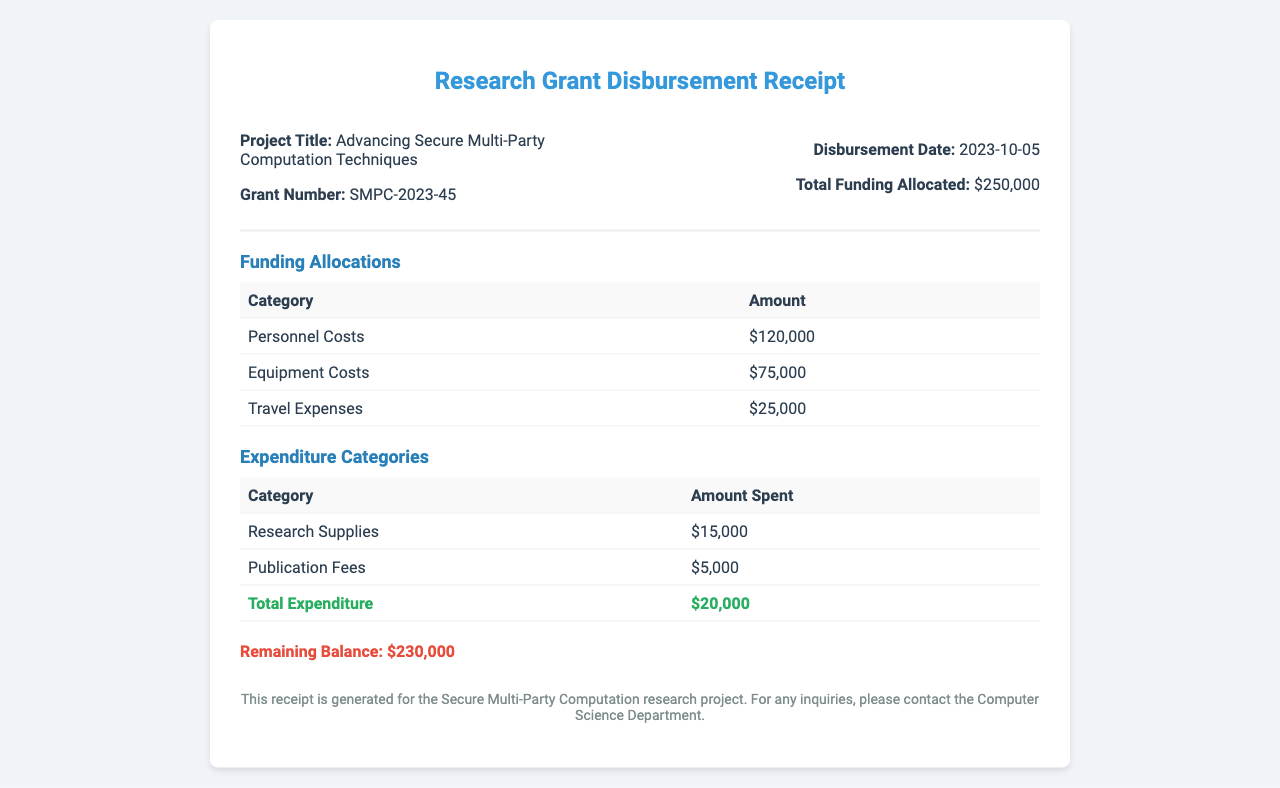What is the project title? The project title is specified in the header section of the document, which is "Advancing Secure Multi-Party Computation Techniques."
Answer: Advancing Secure Multi-Party Computation Techniques What is the grant number? The grant number is indicated alongside the project title, which is "SMPC-2023-45."
Answer: SMPC-2023-45 What is the disbursement date? The disbursement date is found in the header section, listed as "2023-10-05."
Answer: 2023-10-05 What is the total funding allocated? The total funding allocated is explicitly stated in the header as "$250,000."
Answer: $250,000 What amount is allocated for personnel costs? The personnel costs figure can be retrieved from the funding allocations table, which specifies "$120,000."
Answer: $120,000 How much has been spent on research supplies? The amount spent on research supplies is shown in the expenditure categories table as "$15,000."
Answer: $15,000 What is the total expenditure amount? The total expenditure is clearly listed in the expenditure categories table as "$20,000."
Answer: $20,000 What is the remaining balance? The remaining balance is highlighted at the bottom of the document as "$230,000."
Answer: $230,000 What are the categories listed under funding allocations? The funding allocations table includes three categories: Personnel Costs, Equipment Costs, and Travel Expenses.
Answer: Personnel Costs, Equipment Costs, Travel Expenses What is the purpose of this receipt? The purpose of the receipt is specified in the footer, indicating it's for the "Secure Multi-Party Computation research project."
Answer: Secure Multi-Party Computation research project 